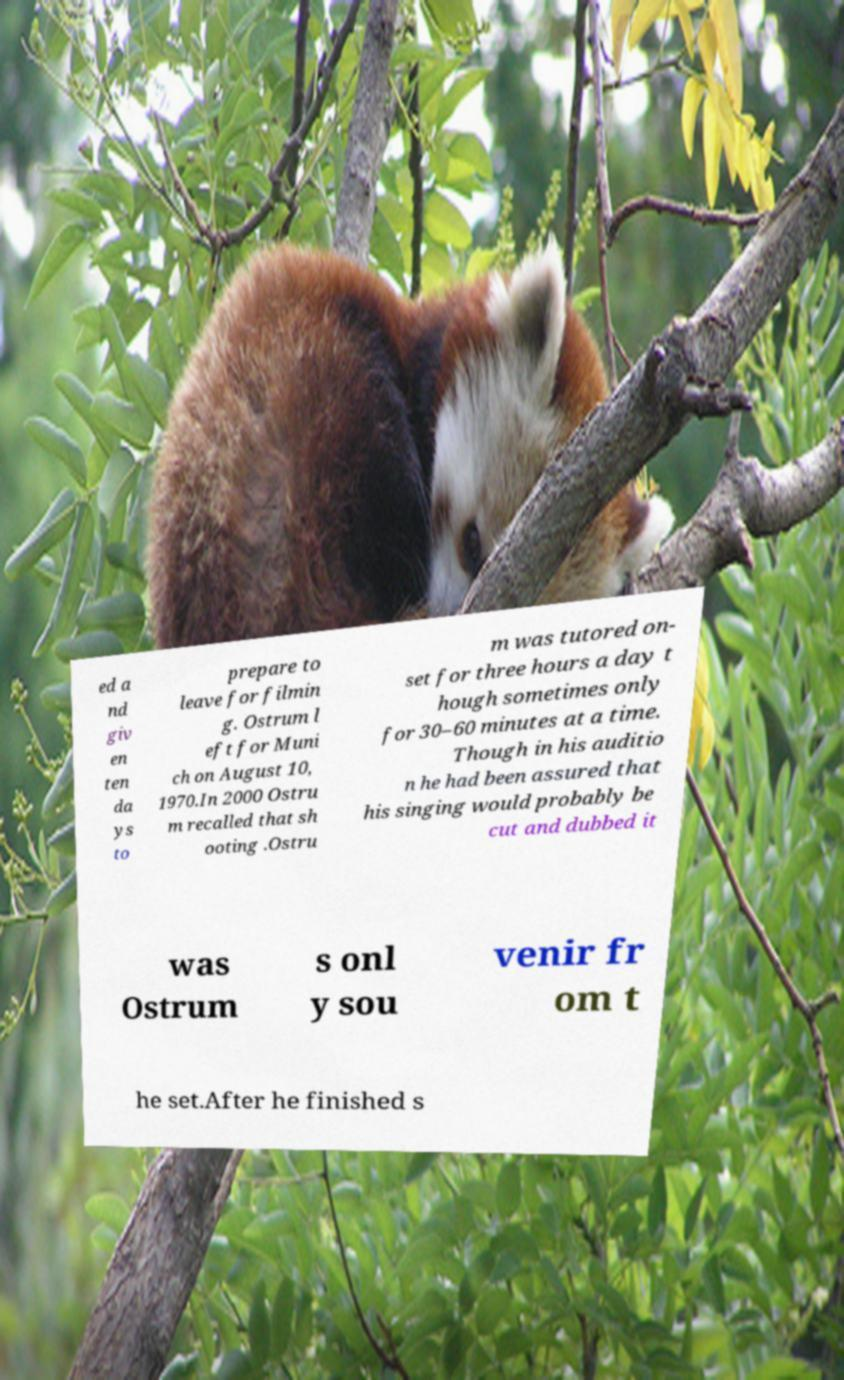Could you assist in decoding the text presented in this image and type it out clearly? ed a nd giv en ten da ys to prepare to leave for filmin g. Ostrum l eft for Muni ch on August 10, 1970.In 2000 Ostru m recalled that sh ooting .Ostru m was tutored on- set for three hours a day t hough sometimes only for 30–60 minutes at a time. Though in his auditio n he had been assured that his singing would probably be cut and dubbed it was Ostrum s onl y sou venir fr om t he set.After he finished s 